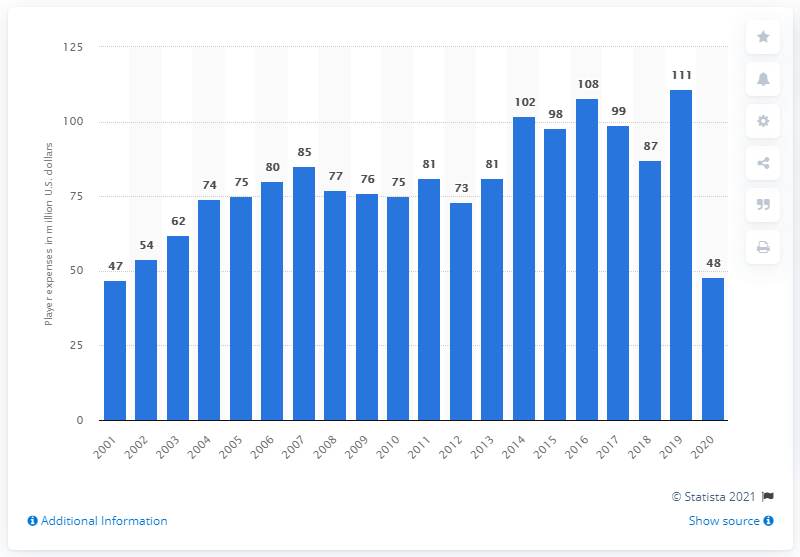Give some essential details in this illustration. The Oakland Athletics had a payroll of approximately 48 million dollars in 2020. 